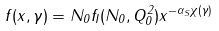Convert formula to latex. <formula><loc_0><loc_0><loc_500><loc_500>f ( x , \gamma ) = N _ { 0 } f _ { I } ( N _ { 0 } , Q _ { 0 } ^ { 2 } ) x ^ { - \alpha _ { S } \chi ( \gamma ) }</formula> 